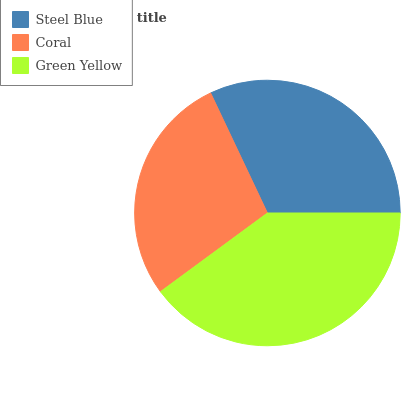Is Coral the minimum?
Answer yes or no. Yes. Is Green Yellow the maximum?
Answer yes or no. Yes. Is Green Yellow the minimum?
Answer yes or no. No. Is Coral the maximum?
Answer yes or no. No. Is Green Yellow greater than Coral?
Answer yes or no. Yes. Is Coral less than Green Yellow?
Answer yes or no. Yes. Is Coral greater than Green Yellow?
Answer yes or no. No. Is Green Yellow less than Coral?
Answer yes or no. No. Is Steel Blue the high median?
Answer yes or no. Yes. Is Steel Blue the low median?
Answer yes or no. Yes. Is Coral the high median?
Answer yes or no. No. Is Green Yellow the low median?
Answer yes or no. No. 